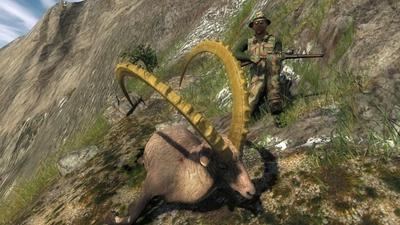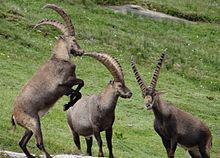The first image is the image on the left, the second image is the image on the right. For the images displayed, is the sentence "An image shows exactly one horned animal, which stands with body angled leftward and head angled rightward." factually correct? Answer yes or no. No. The first image is the image on the left, the second image is the image on the right. Assess this claim about the two images: "There are three antelopes in total.". Correct or not? Answer yes or no. No. 